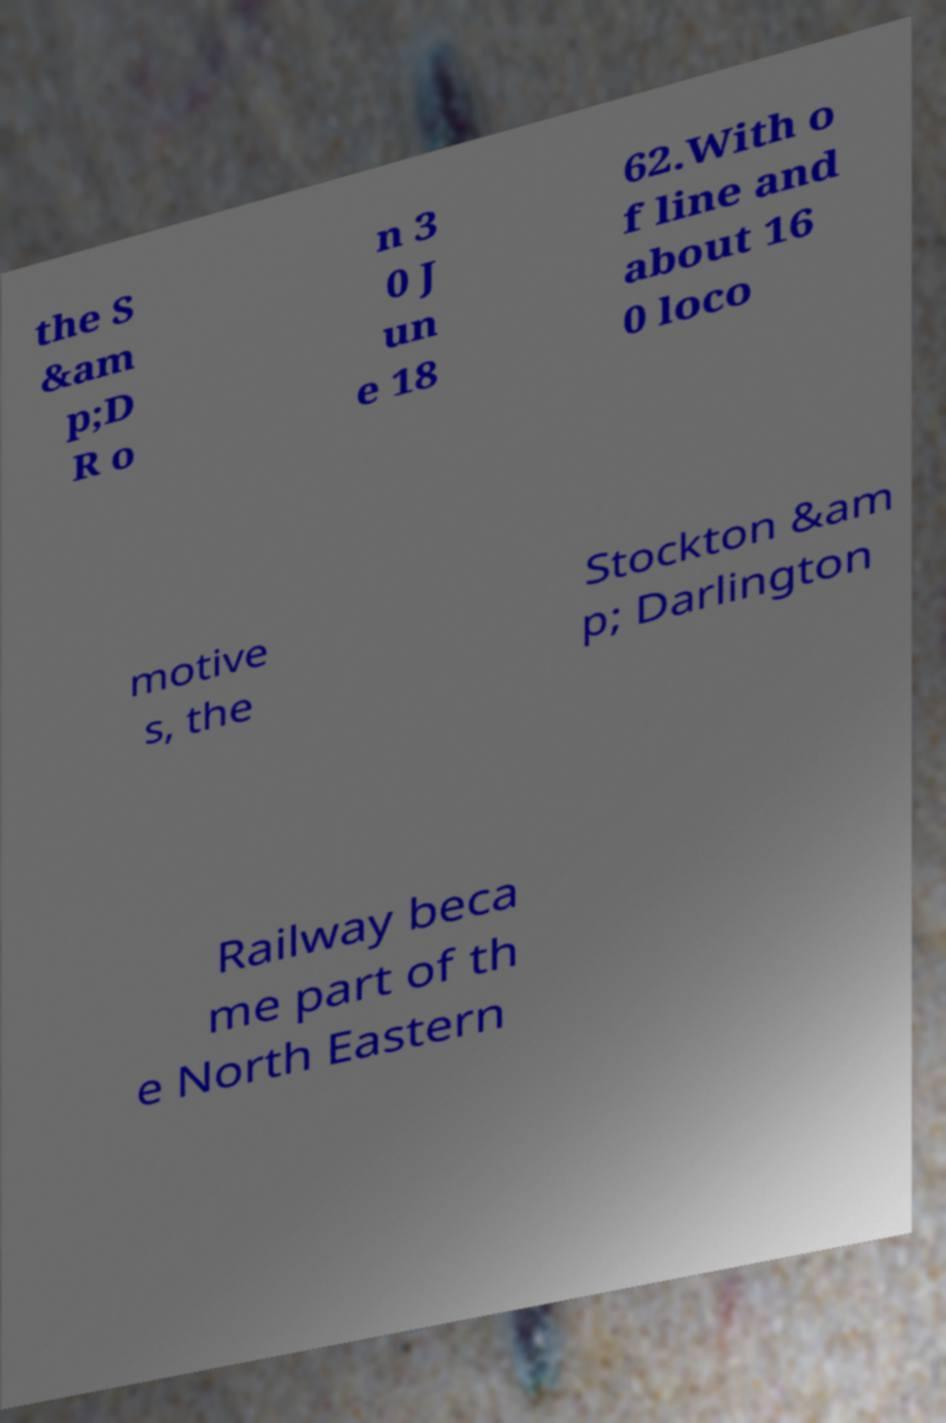For documentation purposes, I need the text within this image transcribed. Could you provide that? the S &am p;D R o n 3 0 J un e 18 62.With o f line and about 16 0 loco motive s, the Stockton &am p; Darlington Railway beca me part of th e North Eastern 